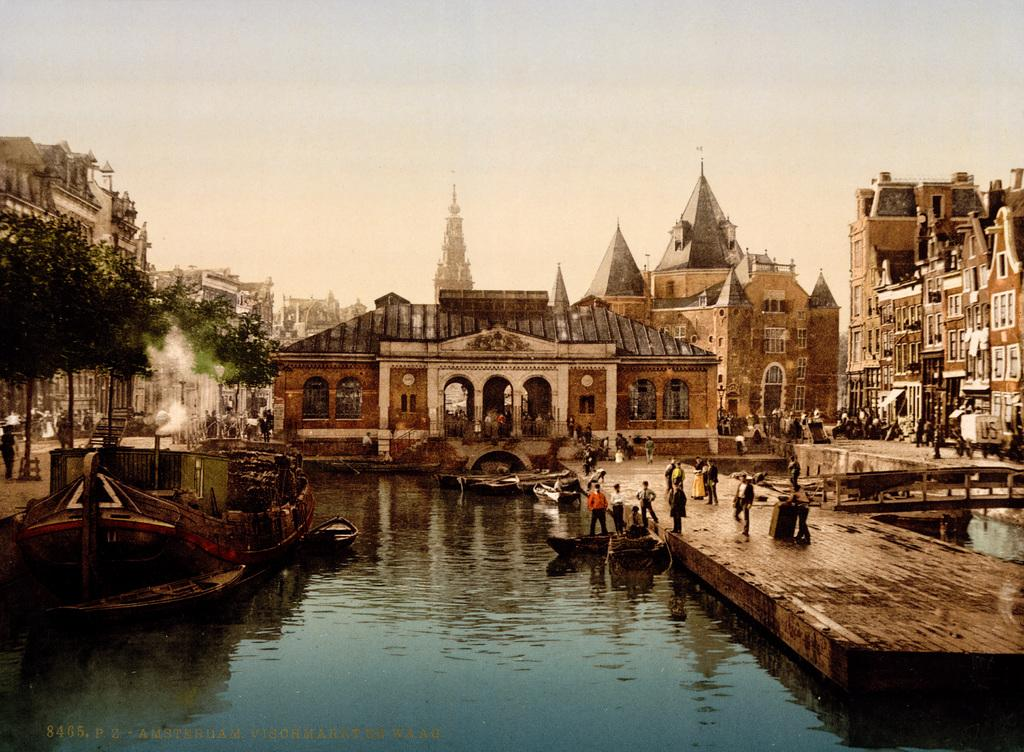What is the main feature of the image? The main feature of the image is water. What else can be seen in the water? There are boats in the image. Are there any people present in the image? Yes, there are people in the image. What other elements can be seen in the image? There are trees, buildings, and the sky visible in the image. What type of property is being sold in the image? There is no indication of any property being sold in the image. Can you tell me how many ovens are visible in the image? There are no ovens present in the image. 